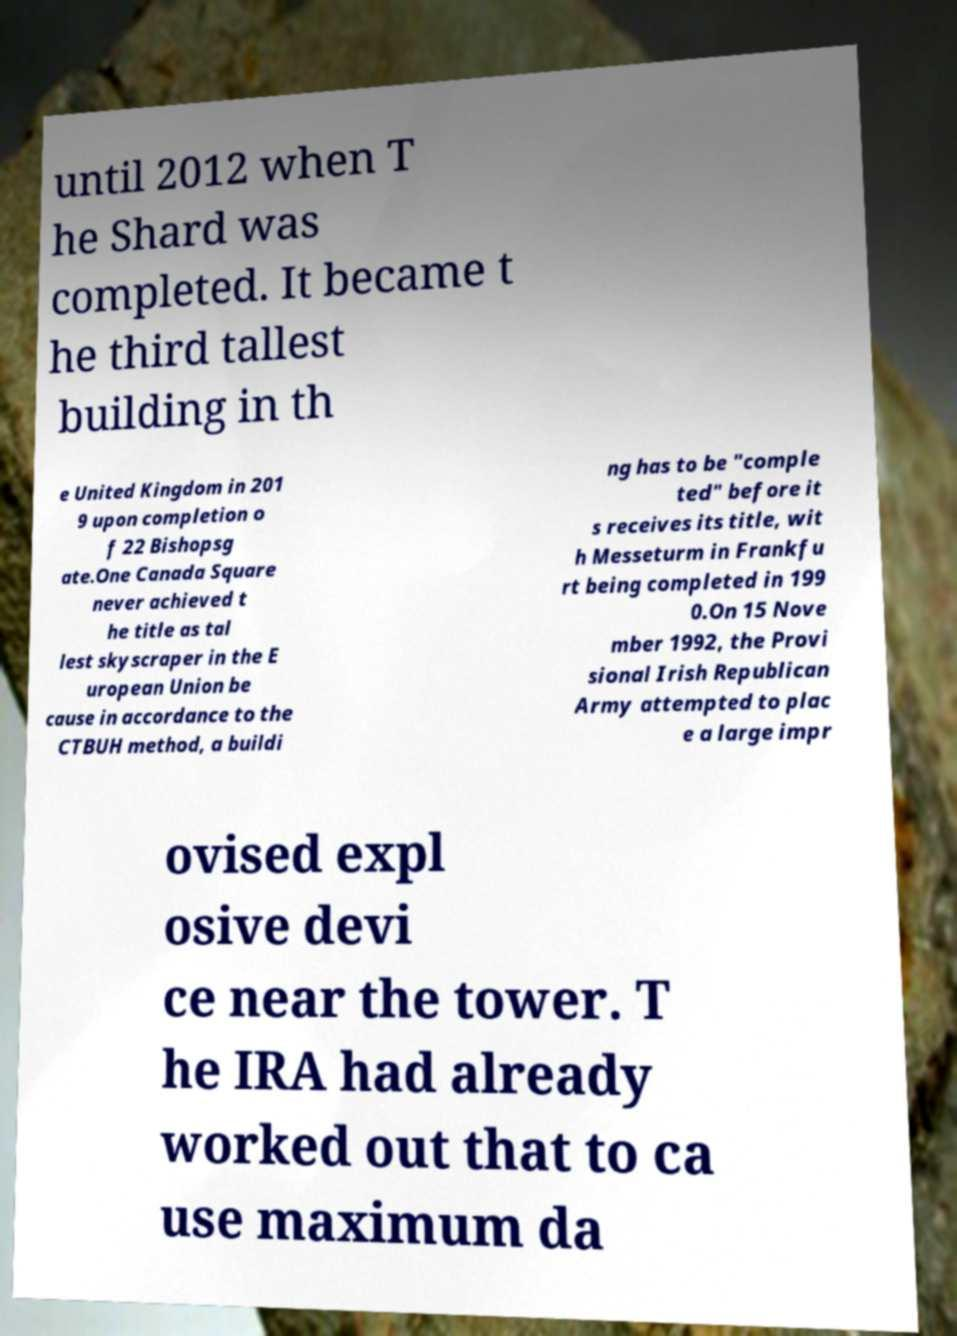Can you accurately transcribe the text from the provided image for me? until 2012 when T he Shard was completed. It became t he third tallest building in th e United Kingdom in 201 9 upon completion o f 22 Bishopsg ate.One Canada Square never achieved t he title as tal lest skyscraper in the E uropean Union be cause in accordance to the CTBUH method, a buildi ng has to be "comple ted" before it s receives its title, wit h Messeturm in Frankfu rt being completed in 199 0.On 15 Nove mber 1992, the Provi sional Irish Republican Army attempted to plac e a large impr ovised expl osive devi ce near the tower. T he IRA had already worked out that to ca use maximum da 